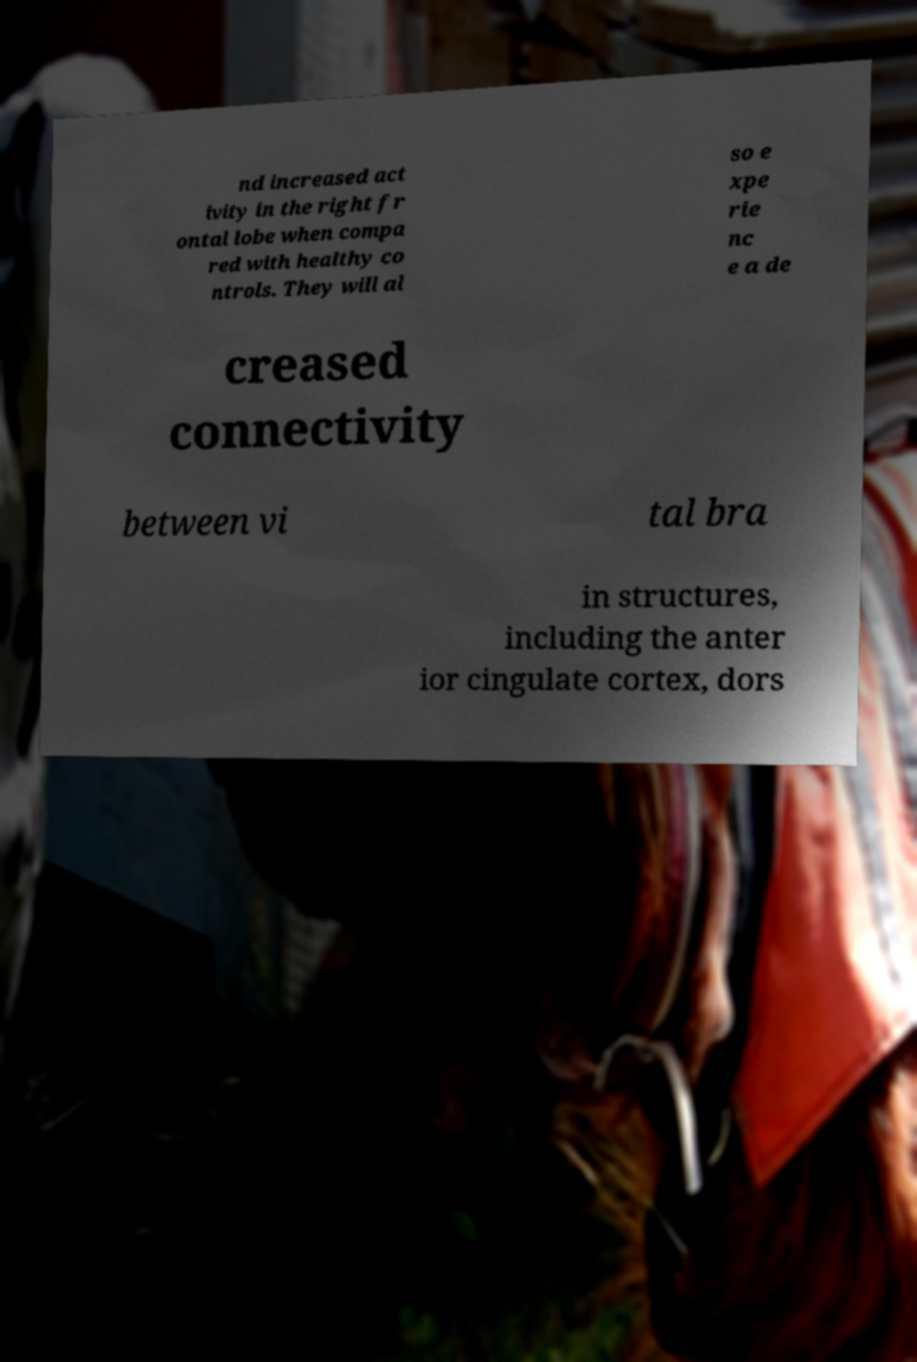There's text embedded in this image that I need extracted. Can you transcribe it verbatim? nd increased act ivity in the right fr ontal lobe when compa red with healthy co ntrols. They will al so e xpe rie nc e a de creased connectivity between vi tal bra in structures, including the anter ior cingulate cortex, dors 